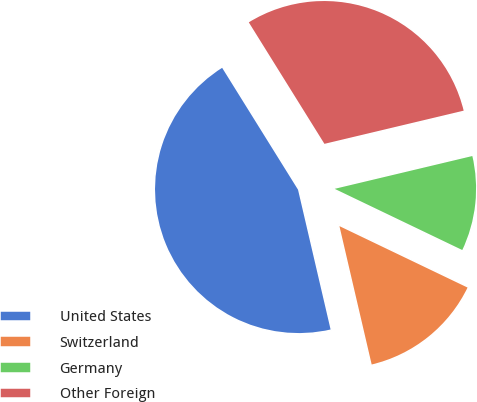<chart> <loc_0><loc_0><loc_500><loc_500><pie_chart><fcel>United States<fcel>Switzerland<fcel>Germany<fcel>Other Foreign<nl><fcel>44.78%<fcel>14.24%<fcel>10.84%<fcel>30.14%<nl></chart> 